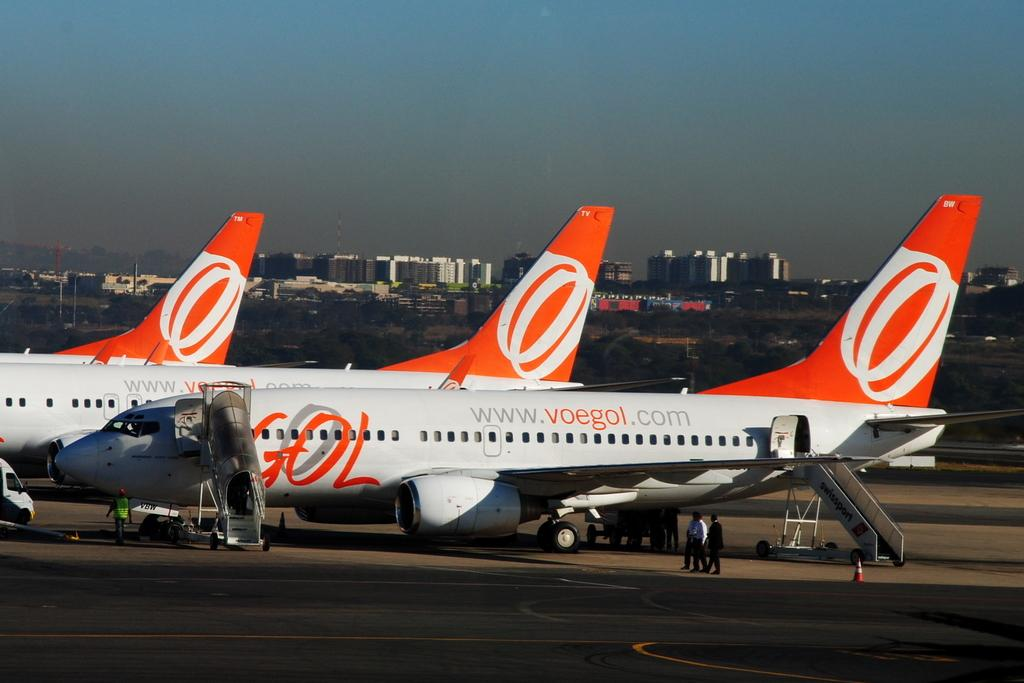What is the main subject of the image? The main subject of the image is airplanes. What objects are present in the image related to maintenance or access? There are ladders in the image. What can be seen happening on the ground in the image? There are people walking on the road in the image. What safety or traffic control items are visible in the image? Road cones are visible in the image. What type of natural elements are present in the image? There are trees in the image. What type of man-made structures are present in the image? There are buildings in the image. What is visible in the background of the image? The sky is visible in the background of the image. Where is the flag located in the image? There is no flag present in the image. What type of popcorn is being served to the people walking on the road in the image? There is no popcorn present in the image; people are walking on the road, but no food items are mentioned or visible. 